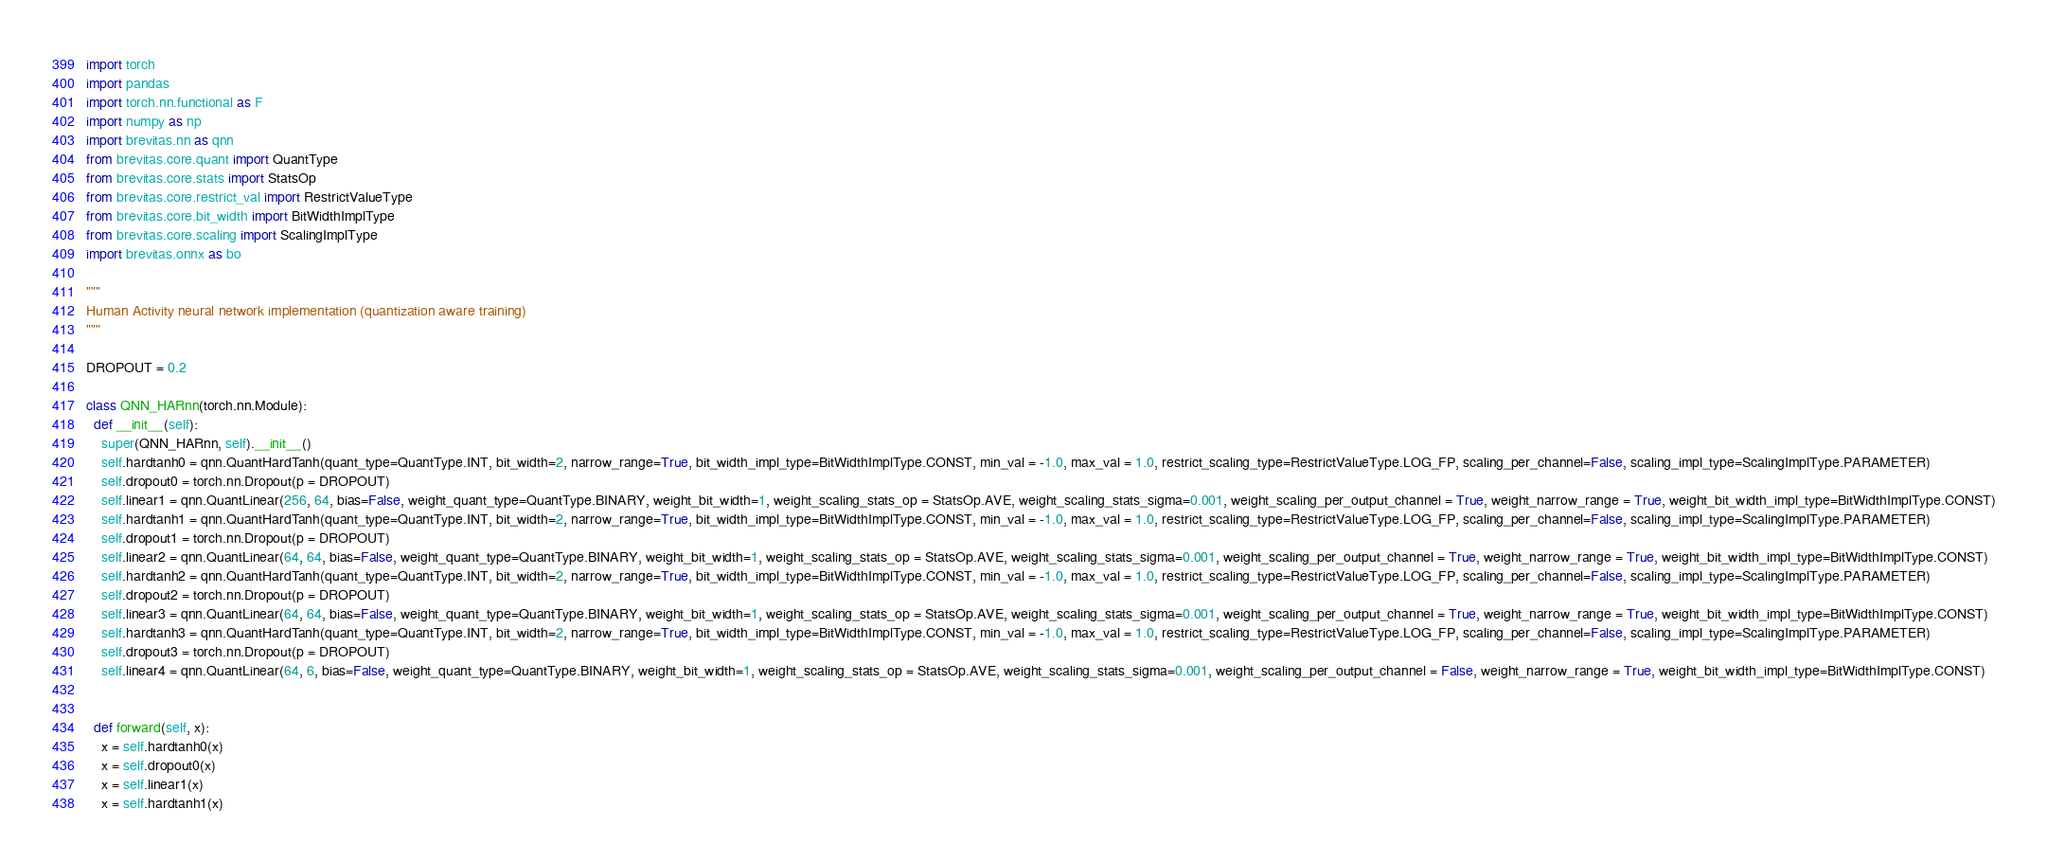<code> <loc_0><loc_0><loc_500><loc_500><_Python_>import torch
import pandas
import torch.nn.functional as F
import numpy as np
import brevitas.nn as qnn
from brevitas.core.quant import QuantType
from brevitas.core.stats import StatsOp
from brevitas.core.restrict_val import RestrictValueType
from brevitas.core.bit_width import BitWidthImplType
from brevitas.core.scaling import ScalingImplType
import brevitas.onnx as bo

"""
Human Activity neural network implementation (quantization aware training)
"""

DROPOUT = 0.2

class QNN_HARnn(torch.nn.Module):
  def __init__(self):
    super(QNN_HARnn, self).__init__()
    self.hardtanh0 = qnn.QuantHardTanh(quant_type=QuantType.INT, bit_width=2, narrow_range=True, bit_width_impl_type=BitWidthImplType.CONST, min_val = -1.0, max_val = 1.0, restrict_scaling_type=RestrictValueType.LOG_FP, scaling_per_channel=False, scaling_impl_type=ScalingImplType.PARAMETER)
    self.dropout0 = torch.nn.Dropout(p = DROPOUT)
    self.linear1 = qnn.QuantLinear(256, 64, bias=False, weight_quant_type=QuantType.BINARY, weight_bit_width=1, weight_scaling_stats_op = StatsOp.AVE, weight_scaling_stats_sigma=0.001, weight_scaling_per_output_channel = True, weight_narrow_range = True, weight_bit_width_impl_type=BitWidthImplType.CONST)
    self.hardtanh1 = qnn.QuantHardTanh(quant_type=QuantType.INT, bit_width=2, narrow_range=True, bit_width_impl_type=BitWidthImplType.CONST, min_val = -1.0, max_val = 1.0, restrict_scaling_type=RestrictValueType.LOG_FP, scaling_per_channel=False, scaling_impl_type=ScalingImplType.PARAMETER)
    self.dropout1 = torch.nn.Dropout(p = DROPOUT)
    self.linear2 = qnn.QuantLinear(64, 64, bias=False, weight_quant_type=QuantType.BINARY, weight_bit_width=1, weight_scaling_stats_op = StatsOp.AVE, weight_scaling_stats_sigma=0.001, weight_scaling_per_output_channel = True, weight_narrow_range = True, weight_bit_width_impl_type=BitWidthImplType.CONST)
    self.hardtanh2 = qnn.QuantHardTanh(quant_type=QuantType.INT, bit_width=2, narrow_range=True, bit_width_impl_type=BitWidthImplType.CONST, min_val = -1.0, max_val = 1.0, restrict_scaling_type=RestrictValueType.LOG_FP, scaling_per_channel=False, scaling_impl_type=ScalingImplType.PARAMETER)
    self.dropout2 = torch.nn.Dropout(p = DROPOUT)
    self.linear3 = qnn.QuantLinear(64, 64, bias=False, weight_quant_type=QuantType.BINARY, weight_bit_width=1, weight_scaling_stats_op = StatsOp.AVE, weight_scaling_stats_sigma=0.001, weight_scaling_per_output_channel = True, weight_narrow_range = True, weight_bit_width_impl_type=BitWidthImplType.CONST)
    self.hardtanh3 = qnn.QuantHardTanh(quant_type=QuantType.INT, bit_width=2, narrow_range=True, bit_width_impl_type=BitWidthImplType.CONST, min_val = -1.0, max_val = 1.0, restrict_scaling_type=RestrictValueType.LOG_FP, scaling_per_channel=False, scaling_impl_type=ScalingImplType.PARAMETER)
    self.dropout3 = torch.nn.Dropout(p = DROPOUT)
    self.linear4 = qnn.QuantLinear(64, 6, bias=False, weight_quant_type=QuantType.BINARY, weight_bit_width=1, weight_scaling_stats_op = StatsOp.AVE, weight_scaling_stats_sigma=0.001, weight_scaling_per_output_channel = False, weight_narrow_range = True, weight_bit_width_impl_type=BitWidthImplType.CONST)


  def forward(self, x):
    x = self.hardtanh0(x)
    x = self.dropout0(x)
    x = self.linear1(x)
    x = self.hardtanh1(x)</code> 